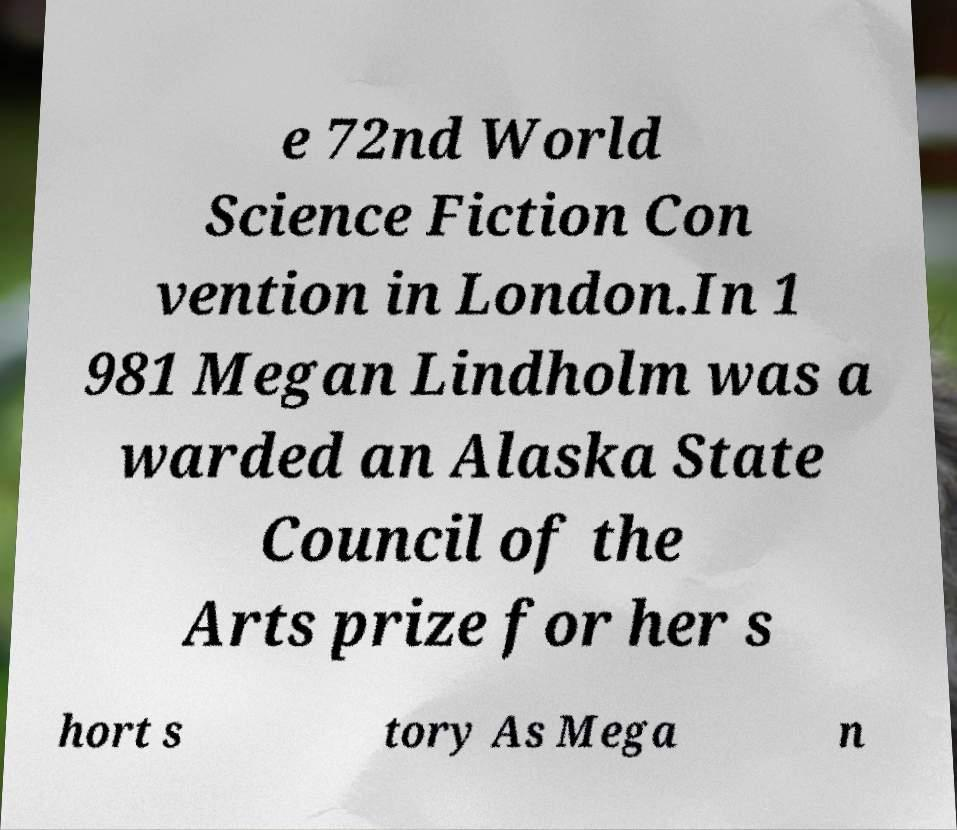For documentation purposes, I need the text within this image transcribed. Could you provide that? e 72nd World Science Fiction Con vention in London.In 1 981 Megan Lindholm was a warded an Alaska State Council of the Arts prize for her s hort s tory As Mega n 